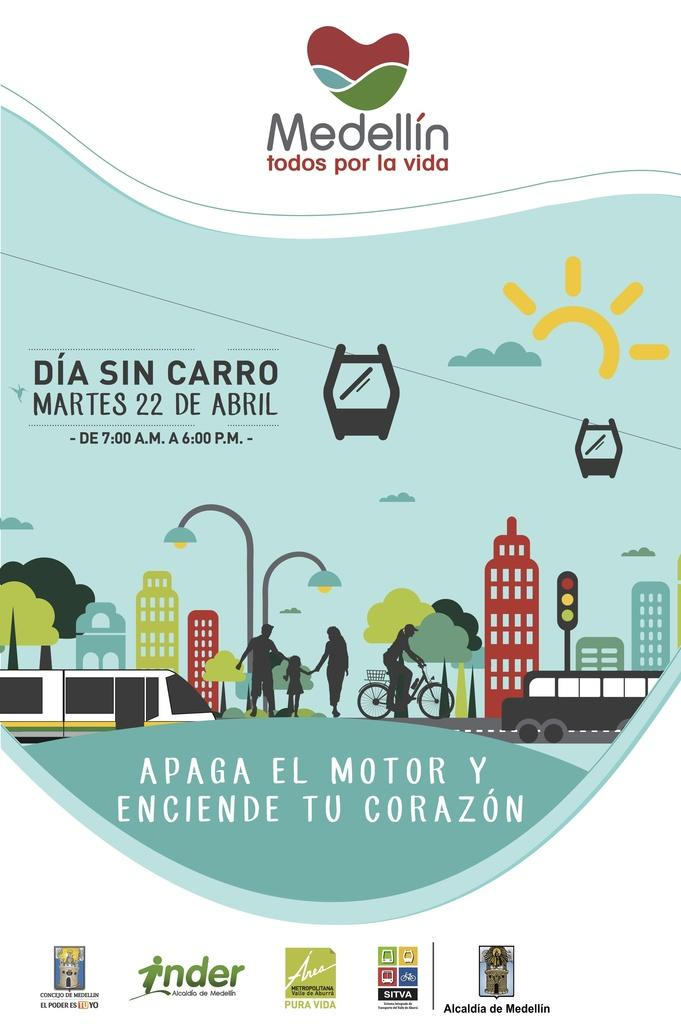<image>
Render a clear and concise summary of the photo. An advertising poster with an outdoor scene by Medellin. 